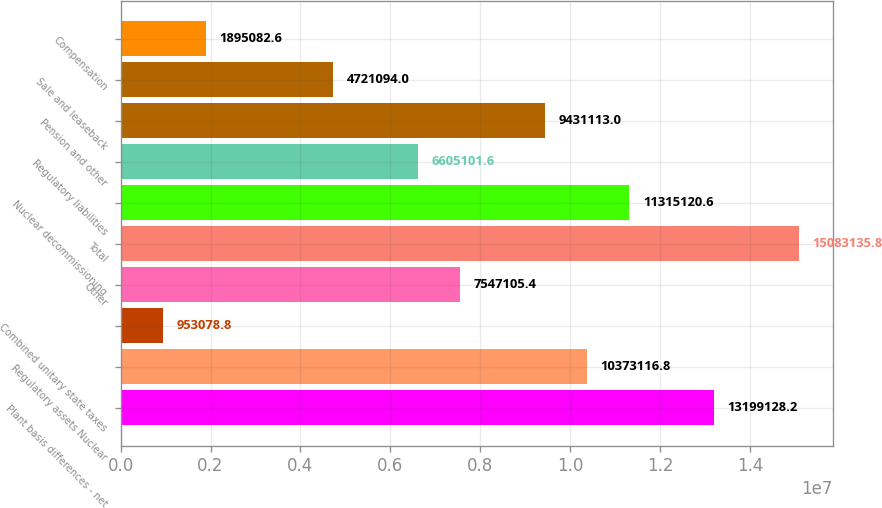Convert chart to OTSL. <chart><loc_0><loc_0><loc_500><loc_500><bar_chart><fcel>Plant basis differences - net<fcel>Regulatory assets Nuclear<fcel>Combined unitary state taxes<fcel>Other<fcel>Total<fcel>Nuclear decommissioning<fcel>Regulatory liabilities<fcel>Pension and other<fcel>Sale and leaseback<fcel>Compensation<nl><fcel>1.31991e+07<fcel>1.03731e+07<fcel>953079<fcel>7.54711e+06<fcel>1.50831e+07<fcel>1.13151e+07<fcel>6.6051e+06<fcel>9.43111e+06<fcel>4.72109e+06<fcel>1.89508e+06<nl></chart> 